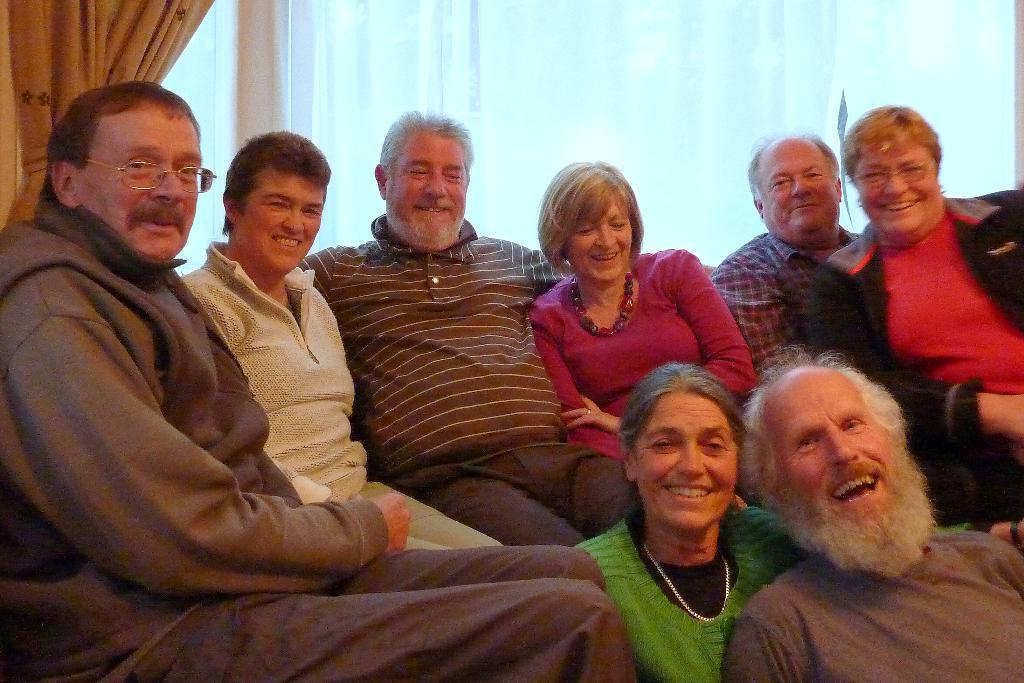How many people are present in the image? There are eight persons in the image. Can you describe the position of two of the persons? Two persons are sitting below in the image. What is the general expression of the people in the image? All of the persons are smiling. What can be seen in the background of the image? There is a window in the background of the image. Is there any window treatment present in the image? Yes, there is a curtain associated with the window. Reasoning: Let's think step by step by step in order to produce the conversation. We start by identifying the number of people in the image, which is eight. Then, we describe the position of two of the persons, who are sitting below. Next, we mention the general expression of the people, which is smiling. Finally, we describe the background of the image, including the window and the curtain. Absurd Question/Answer: What type of machine is being used for growth in the image? There is no machine or growth-related activity present in the image. What is the main subject of the image? The main subject of the image is a car. Can you describe the color of the car? The car is red. How many wheels does the car have? The car has four wheels. What can be seen in the background of the image? There is a road in the image. What is the condition of the road? The road is paved. Reasoning: Let's think step by step in order to produce the conversation. We start by identifying the main subject of the image, which is the car. Then, we describe specific features of the car, such as its color and the number of wheels. Next, we observe the background of the image, noting that there is a road. Finally, we describe the condition of the road, which is paved. Absurd Question/Answer: Can you tell me how many parrots are sitting on the car in the image? There are no parrots present in the image; it features 